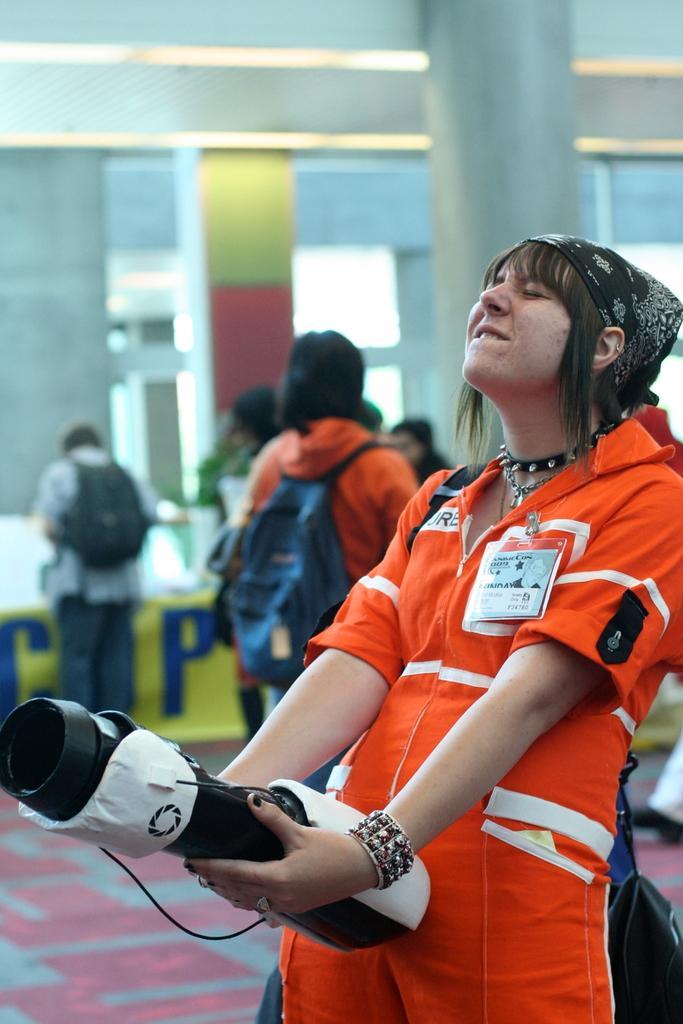How would you summarize this image in a sentence or two? There is a woman in orange color dress smiling, standing and holding an object. In the background, there are persons on the floor, there are pillars and there is wall. 